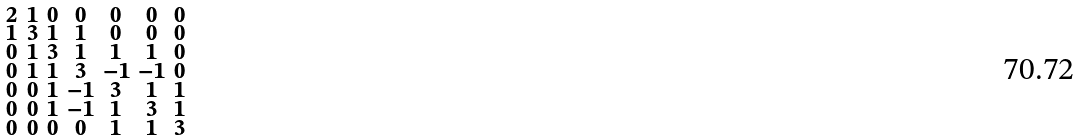<formula> <loc_0><loc_0><loc_500><loc_500>\begin{smallmatrix} 2 & 1 & 0 & 0 & 0 & 0 & 0 \\ 1 & 3 & 1 & 1 & 0 & 0 & 0 \\ 0 & 1 & 3 & 1 & 1 & 1 & 0 \\ 0 & 1 & 1 & 3 & - 1 & - 1 & 0 \\ 0 & 0 & 1 & - 1 & 3 & 1 & 1 \\ 0 & 0 & 1 & - 1 & 1 & 3 & 1 \\ 0 & 0 & 0 & 0 & 1 & 1 & 3 \end{smallmatrix}</formula> 